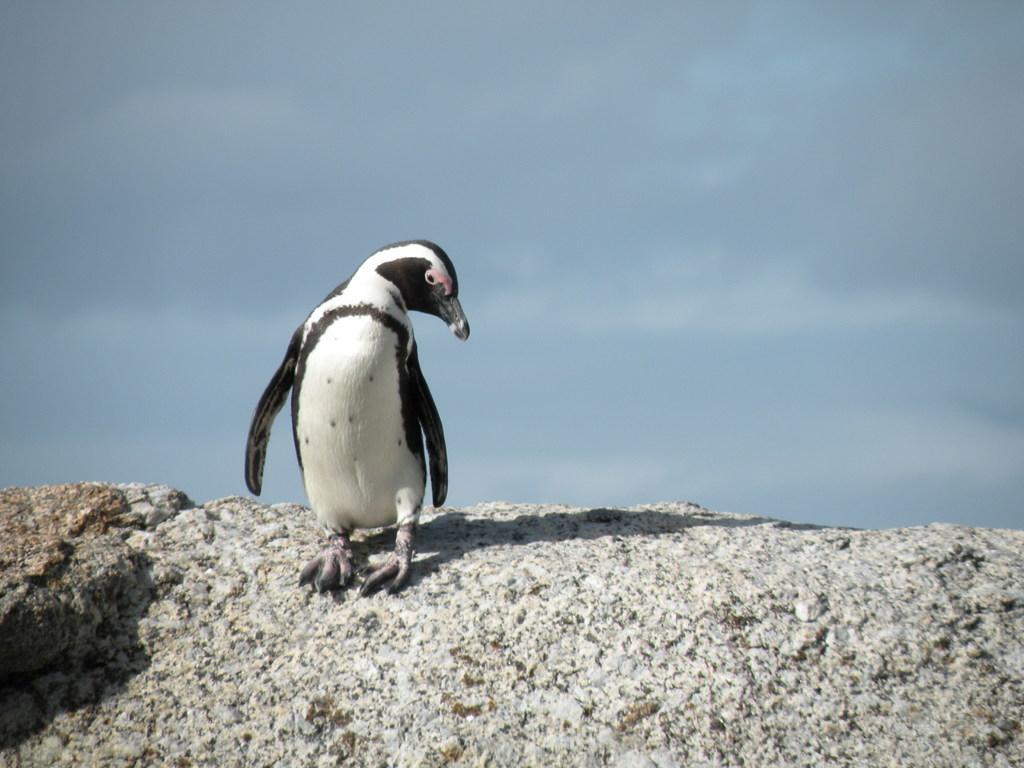Describe this image in one or two sentences. In this image, I can see a penguin on a rock. In the background, there is the sky. 